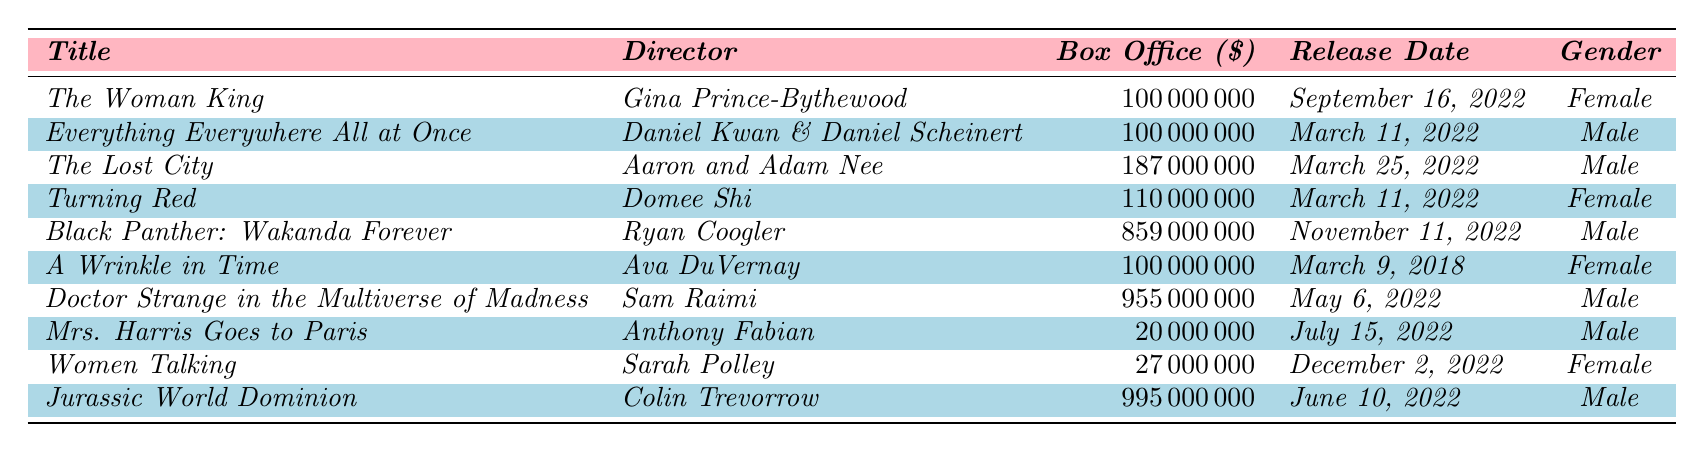What is the box office gross for "The Woman King"? The table shows that "The Woman King," directed by Gina Prince-Bythewood, has a box office gross of $100,000,000.
Answer: $100,000,000 Which film had the highest box office gross among films directed by men? By examining the table, "Jurassic World Dominion" directed by Colin Trevorrow has the highest box office gross at $995,000,000 among male-directed films.
Answer: $995,000,000 What is the total box office gross for all films directed by women? Summing the box office grosses for films directed by women: "The Woman King" ($100,000,000) + "Turning Red" ($110,000,000) + "Women Talking" ($27,000,000) gives a total of $337,000,000.
Answer: $337,000,000 Is "Everything Everywhere All at Once" a film directed by a woman? Based on the table, "Everything Everywhere All at Once" is directed by Daniel Kwan & Daniel Scheinert, which identifies it as a male-directed film.
Answer: No What is the average box office gross of films directed by female directors? The total box office gross of female-directed films is $337,000,000 from 3 films. Dividing this by 3 gives an average of $112,333,333.33, which rounds to about $112,000,000.
Answer: $112,000,000 How much more did "Black Panther: Wakanda Forever" gross than "Women Talking"? "Black Panther: Wakanda Forever" grossed $859,000,000 while "Women Talking" grossed $27,000,000. The difference is $859,000,000 - $27,000,000 = $832,000,000.
Answer: $832,000,000 Was the box office gross for films directed by men overall higher than that of women in 2022? Total for male-directed films: $100,000,000 + $187,000,000 + $859,000,000 + $955,000,000 + $20,000,000 + $995,000,000 equals $3,116,000,000. Female-directed films total $337,000,000. Since $3,116,000,000 > $337,000,000, the answer is yes.
Answer: Yes What is the release date for "Turning Red"? According to the table, "Turning Red," directed by Domee Shi, was released on March 11, 2022.
Answer: March 11, 2022 How many films in the table were released in March 2022? The table lists three films released in March 2022: "Everything Everywhere All at Once," "Turning Red," and "The Lost City." Therefore, the count is 3.
Answer: 3 What percentage of the total box office revenue was earned by "Doctor Strange in the Multiverse of Madness"? The total box office revenue of all films is $4,156,000,000 ($3,116,000,000 men + $337,000,000 women + $955,000,000). "Doctor Strange..." grossed $955,000,000. The percentage is ($955,000,000 / $4,156,000,000) * 100 = 22.96%.
Answer: 22.96% 